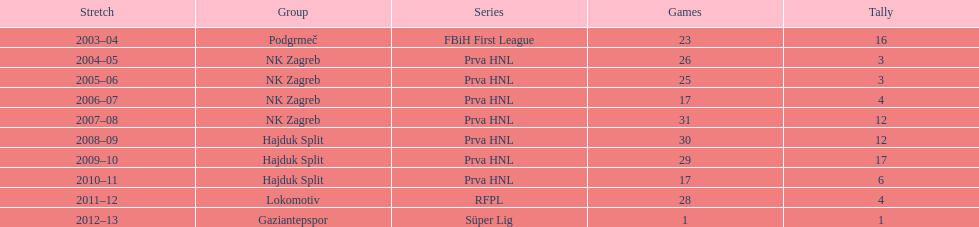What is the highest number of goals scored by senijad ibri&#269;i&#263; in a season? 35. 